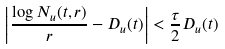Convert formula to latex. <formula><loc_0><loc_0><loc_500><loc_500>\left | \frac { \log N _ { u } ( t , r ) } { r } - D _ { u } ( t ) \right | < \frac { \tau } { 2 } D _ { u } ( t )</formula> 